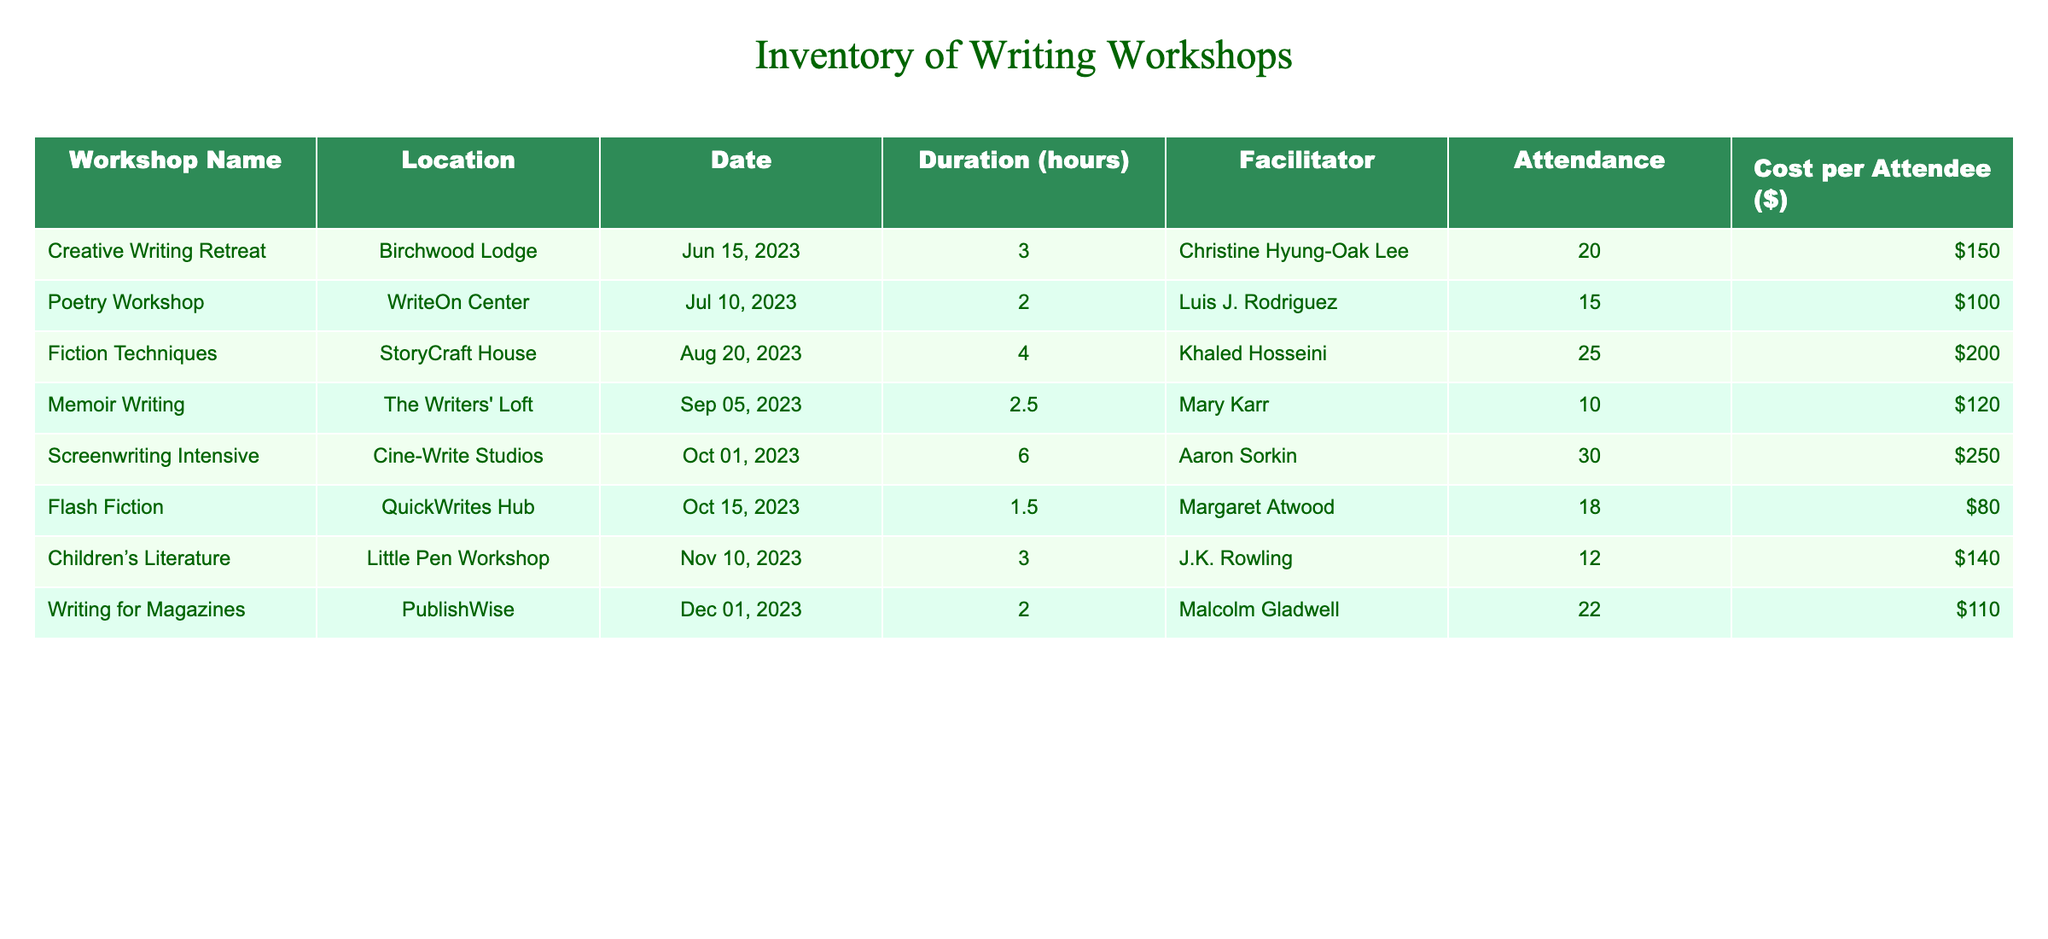What is the date of the "Screenwriting Intensive" workshop? The "Screenwriting Intensive" workshop is listed in the table, and the date associated with it is provided in the Date column. I can see it is on October 1, 2023.
Answer: October 1, 2023 How many attendees participated in the "Fiction Techniques" workshop? Looking at the "Fiction Techniques" workshop row, the Attendance column indicates that 25 attendees participated in this workshop.
Answer: 25 What is the total cost of attendance for the "Memoir Writing" workshop? The "Memoir Writing" workshop has an attendance of 10 and a cost per attendee of $120. By multiplying these two values (10 * 120), the total cost of attendance is calculated as $1,200.
Answer: $1,200 Is there any workshop facilitated by J.K. Rowling? By scanning through the facilitator names in the table, I see that J.K. Rowling is listed as the facilitator for the "Children’s Literature" workshop.
Answer: Yes What is the average attendance across all workshops? To find the average attendance, I first sum all the attendees: 20 + 15 + 25 + 10 + 30 + 18 + 12 + 22 = 152. There are 8 workshops, so I divide the total attendance (152) by the number of workshops (8) to get the average: 152 / 8 = 19.
Answer: 19 Which workshop has the highest cost per attendee? Looking through the Cost per Attendee column, I see that the "Screenwriting Intensive" workshop has the highest cost of $250 per attendee when compared to the other workshops.
Answer: Screenwriting Intensive How many workshops have a duration of less than 3 hours? I can find the workshops with a duration of less than 3 hours by checking the Duration column. The "Flash Fiction" workshop (1.5 hours) and "Memoir Writing" workshop (2.5 hours) fit this criterion. Thus, there are 2 such workshops.
Answer: 2 What is the difference in attendance between the "Creative Writing Retreat" and "Screenwriting Intensive" workshops? The "Creative Writing Retreat" has 20 attendees while the "Screenwriting Intensive" has 30 attendees. To find the difference, I subtract the attendance of the Creative Writing Retreat from that of the Screenwriting Intensive: 30 - 20 = 10.
Answer: 10 Which workshop took place in August? By looking at the Date column in the table, I see that the "Fiction Techniques" workshop took place on August 20, 2023.
Answer: Fiction Techniques 